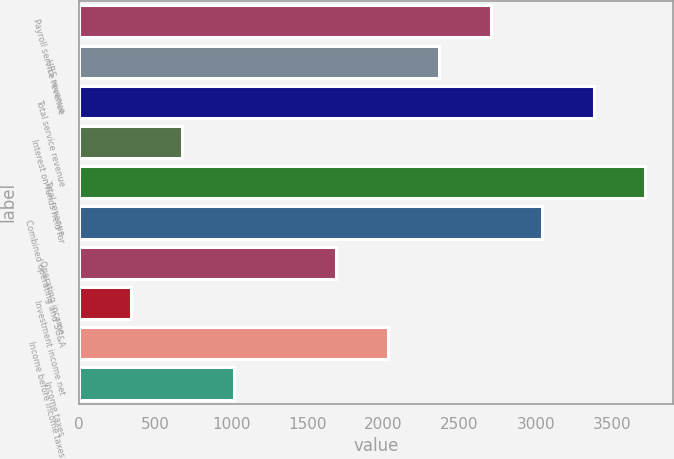Convert chart. <chart><loc_0><loc_0><loc_500><loc_500><bar_chart><fcel>Payroll service revenue<fcel>HRS revenue<fcel>Total service revenue<fcel>Interest on funds held for<fcel>Total revenue<fcel>Combined operating and SG&A<fcel>Operating income<fcel>Investment income net<fcel>Income before income taxes<fcel>Income taxes<nl><fcel>2705.22<fcel>2367.39<fcel>3380.88<fcel>678.24<fcel>3718.71<fcel>3043.05<fcel>1691.73<fcel>340.41<fcel>2029.56<fcel>1016.07<nl></chart> 